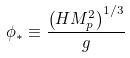Convert formula to latex. <formula><loc_0><loc_0><loc_500><loc_500>\phi _ { * } \equiv \frac { \left ( H M _ { p } ^ { 2 } \right ) ^ { 1 / 3 } } { g }</formula> 